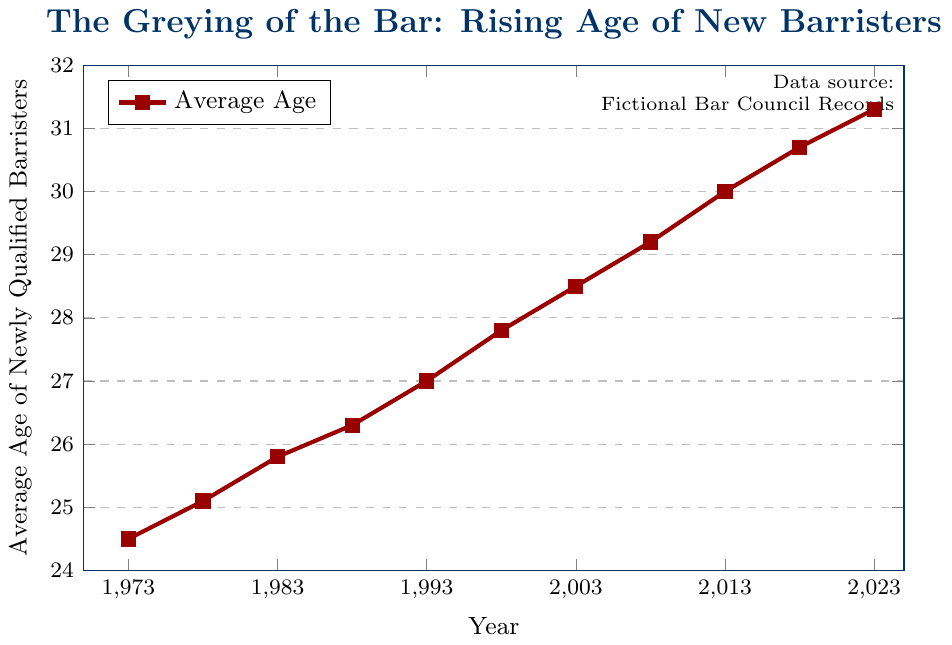What's the highest average age of newly qualified barristers in the data? The highest point on the graph represents the highest average age. The point at the year 2023 is at 31.3.
Answer: 31.3 In what year did the average age of newly qualified barristers first reach 30? Check the line chart for the year where the data point first hits or exceeds 30. In 2013, the average age is 30.0.
Answer: 2013 Compare the average age in 1988 and 1998. Which year had a higher average age, and by how much? The data points for 1988 and 1998 show average ages of 26.3 and 27.8 respectively. The difference is 27.8 - 26.3 = 1.5.
Answer: 1998 by 1.5 From 1973 to 2023, by how many years has the average age of newly qualified barristers increased? The initial value in 1973 is 24.5, and the final value in 2023 is 31.3. Calculate the difference: 31.3 - 24.5 = 6.8.
Answer: 6.8 What's the average age of newly qualified barristers during the first 25 years (1973 to 1998)? Sum the average ages for the years 1973 through 1998 and divide by the number of data points: (24.5 + 25.1 + 25.8 + 26.3 + 27.0 + 27.8) / 6 = 26.08.
Answer: 26.08 How does the trend in the average age of newly qualified barristers appear over the last 50 years? Observe the overall pattern in the line chart. The line consistently rises indicating an increasing trend in the average age.
Answer: Increasing What was the percentage increase in the average age of newly qualified barristers from 1993 to 2003? The values at 1993 and 2003 are 27.0 and 28.5 respectively. Calculate the percentage increase: ((28.5 - 27.0) / 27.0) * 100 ≈ 5.56%.
Answer: 5.56% What is the median average age of newly qualified barristers over the 50 years? Order the 11 data points and find the middle value. The middle value (6th) is for the year 1998, which is 27.8.
Answer: 27.8 